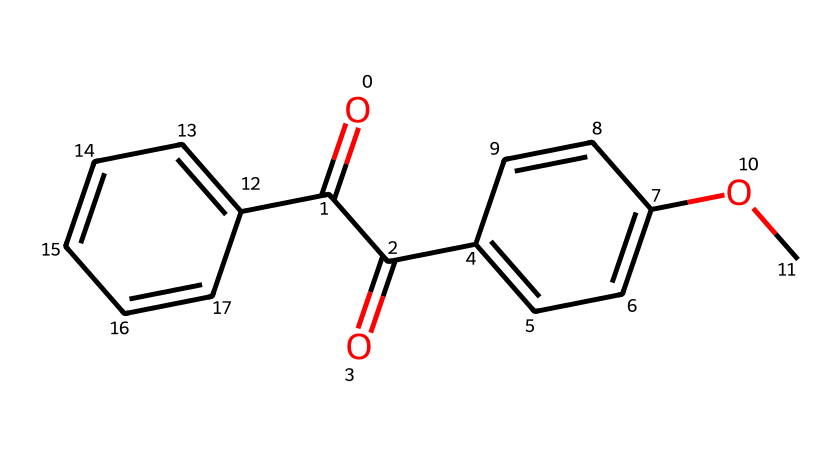What functional groups are present in this chemical? The chemical contains carbonyl functional groups (C=O) as indicated by the double-bonded oxygen atoms. There are also ether groups (C-O-C) as shown in the structure where an oxygen atom is connected to two carbon atoms.
Answer: carbonyl and ether How many rings are present in the structure? Examining the chemical structure, two ring systems are apparent. One ring is aromatic as indicated by the alternating single and double bonds in the benzene-like portions of the structure, while the other might have similar characteristics based on the connectivity of atoms.
Answer: two What is the molecular formula of this sunscreen active ingredient? By counting the atoms represented in the SMILES notation, the molecular formula can be derived. It shows the presence of 18 carbons (C), 16 hydrogens (H), and 4 oxygens (O), leading to the formula C18H16O4.
Answer: C18H16O4 Which part of the chemical structure is likely responsible for UV absorption? The conjugated double bond system typically associated with aromatic rings allows for the delocalization of electrons, which is critical for light absorption, especially in the UV range. This is evidenced by the presence of aromatic rings in the structure.
Answer: aromatic rings Is this compound likely to be hydrophilic or hydrophobic? The presence of long hydrocarbon chains and fewer polar groups suggests the compound is more hydrophobic, making it less soluble in water. The structure contains more carbon atoms than functional groups that can interact with water.
Answer: hydrophobic 